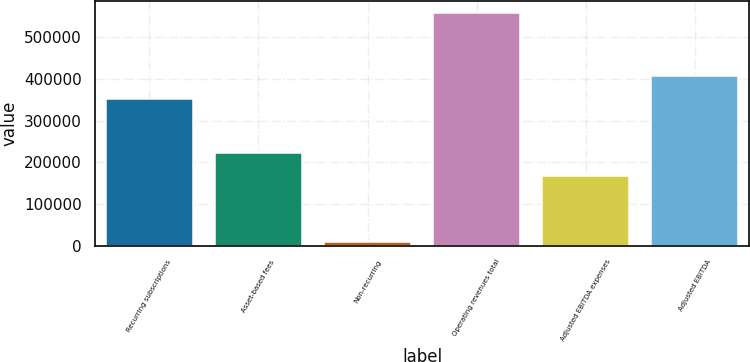<chart> <loc_0><loc_0><loc_500><loc_500><bar_chart><fcel>Recurring subscriptions<fcel>Asset-based fees<fcel>Non-recurring<fcel>Operating revenues total<fcel>Adjusted EBITDA expenses<fcel>Adjusted EBITDA<nl><fcel>353136<fcel>221088<fcel>7854<fcel>558964<fcel>165977<fcel>408247<nl></chart> 